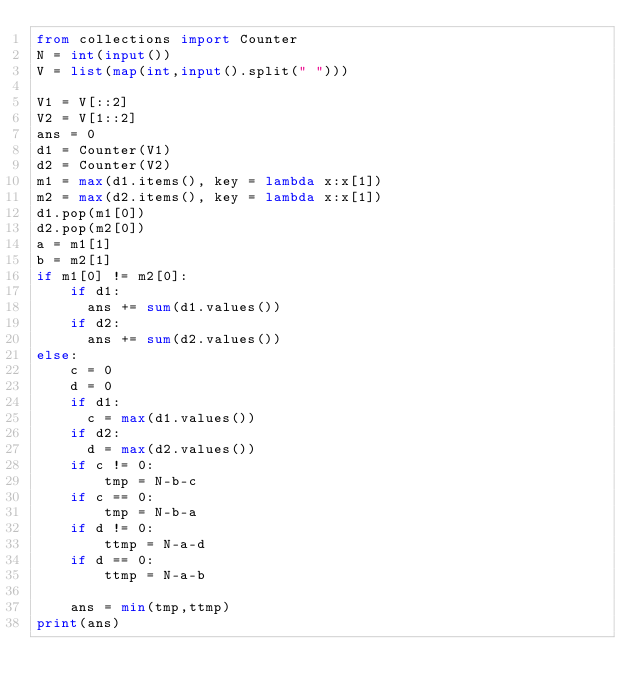<code> <loc_0><loc_0><loc_500><loc_500><_Python_>from collections import Counter
N = int(input())
V = list(map(int,input().split(" ")))

V1 = V[::2]
V2 = V[1::2]
ans = 0
d1 = Counter(V1)
d2 = Counter(V2)
m1 = max(d1.items(), key = lambda x:x[1])
m2 = max(d2.items(), key = lambda x:x[1])
d1.pop(m1[0])
d2.pop(m2[0])
a = m1[1]
b = m2[1]
if m1[0] != m2[0]:
    if d1:
      ans += sum(d1.values())
    if d2:
      ans += sum(d2.values())
else:
    c = 0
    d = 0
    if d1:
	    c = max(d1.values())
    if d2:
	    d = max(d2.values())
    if c != 0:
        tmp = N-b-c
    if c == 0:
        tmp = N-b-a
    if d != 0:
        ttmp = N-a-d
    if d == 0:
        ttmp = N-a-b
    
    ans = min(tmp,ttmp)
print(ans)</code> 